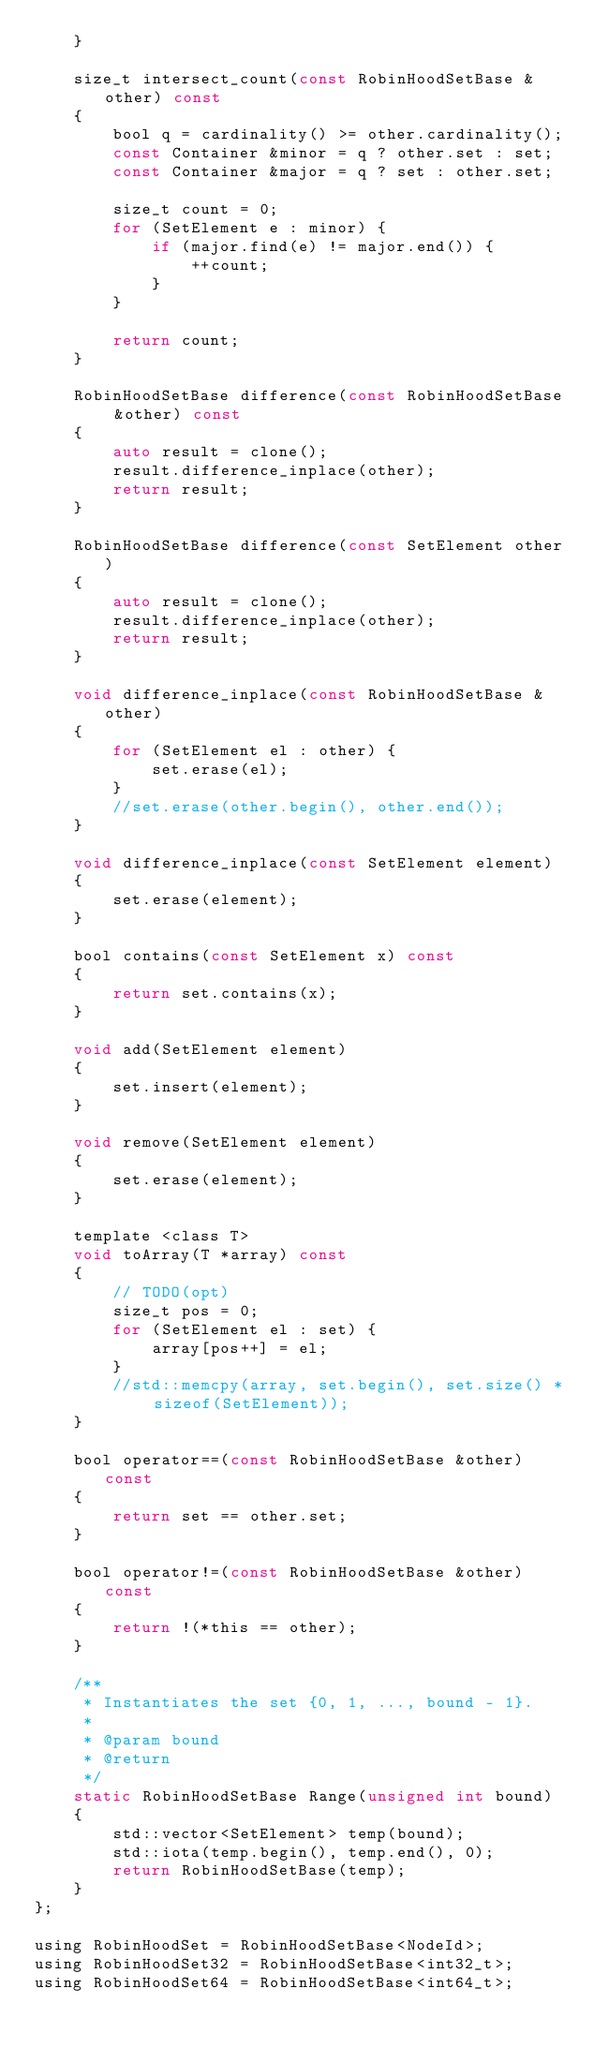Convert code to text. <code><loc_0><loc_0><loc_500><loc_500><_C_>    }

    size_t intersect_count(const RobinHoodSetBase &other) const
    {
        bool q = cardinality() >= other.cardinality();
        const Container &minor = q ? other.set : set;
        const Container &major = q ? set : other.set;

        size_t count = 0;
        for (SetElement e : minor) {
            if (major.find(e) != major.end()) {
                ++count;
            }
        }

        return count;
    }

    RobinHoodSetBase difference(const RobinHoodSetBase &other) const
    {
        auto result = clone();
        result.difference_inplace(other);
        return result;
    }

    RobinHoodSetBase difference(const SetElement other)
    {
        auto result = clone();
        result.difference_inplace(other);
        return result;
    }

    void difference_inplace(const RobinHoodSetBase &other)
    {
        for (SetElement el : other) {
            set.erase(el);
        }
        //set.erase(other.begin(), other.end());
    }

    void difference_inplace(const SetElement element)
    {
        set.erase(element);
    }

    bool contains(const SetElement x) const
    {
        return set.contains(x);
    }

    void add(SetElement element)
    {
        set.insert(element);
    }

    void remove(SetElement element)
    {
        set.erase(element);
    }

    template <class T>
    void toArray(T *array) const
    {
        // TODO(opt)
        size_t pos = 0;
        for (SetElement el : set) {
            array[pos++] = el;
        }
        //std::memcpy(array, set.begin(), set.size() * sizeof(SetElement));
    }

    bool operator==(const RobinHoodSetBase &other) const
    {
        return set == other.set;
    }

    bool operator!=(const RobinHoodSetBase &other) const
    {
        return !(*this == other);
    }

    /**
     * Instantiates the set {0, 1, ..., bound - 1}.
     *
     * @param bound
     * @return
     */
    static RobinHoodSetBase Range(unsigned int bound)
    {
        std::vector<SetElement> temp(bound);
        std::iota(temp.begin(), temp.end(), 0);
        return RobinHoodSetBase(temp);
    }
};

using RobinHoodSet = RobinHoodSetBase<NodeId>;
using RobinHoodSet32 = RobinHoodSetBase<int32_t>;
using RobinHoodSet64 = RobinHoodSetBase<int64_t>;
</code> 